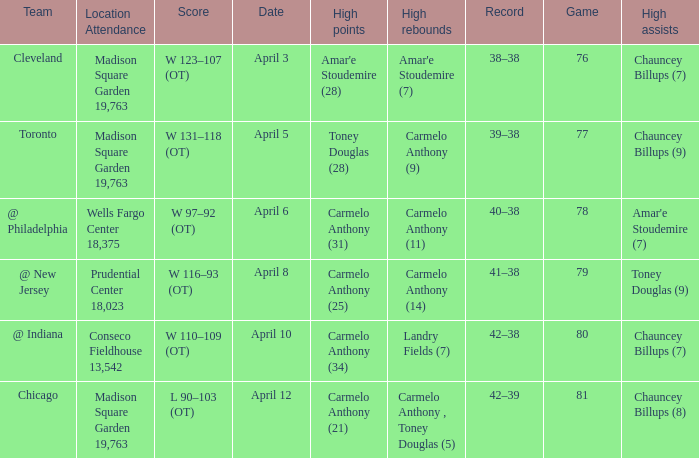Name the location attendance april 5 Madison Square Garden 19,763. 